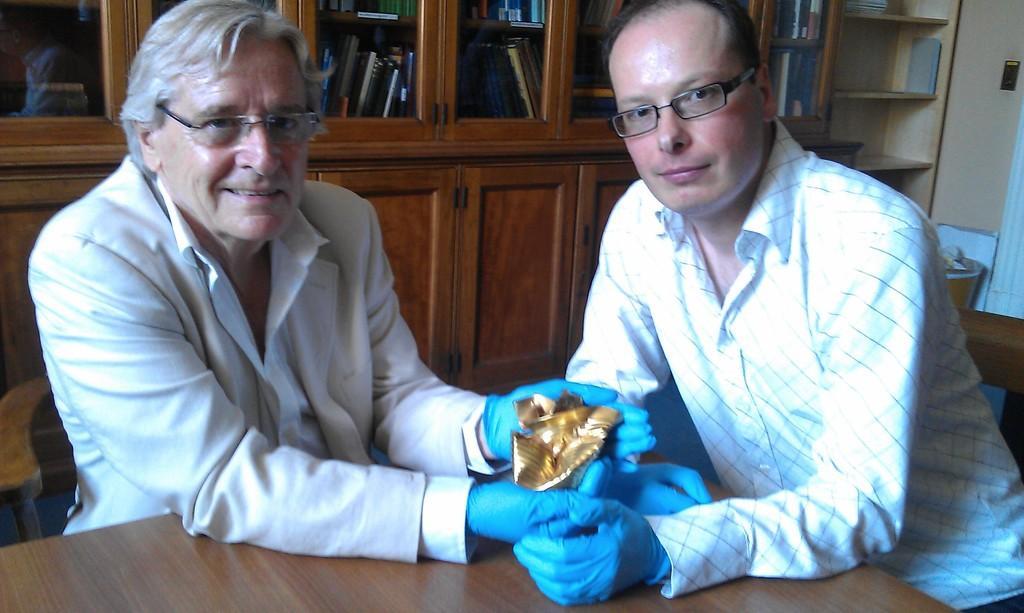Could you give a brief overview of what you see in this image? This image is taken indoors. At the bottom of the image there is a table. On the left side of the image a man is sitting on the chair and he is holding something in his hands. On the right side of the image a man is sitting on the chair. In the background there is a wall with many cupboards and shelves. There are many things in the cupboards. 